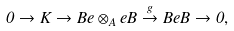Convert formula to latex. <formula><loc_0><loc_0><loc_500><loc_500>0 \to K \to B e \otimes _ { A } e B \overset { g } \to B e B \to 0 ,</formula> 